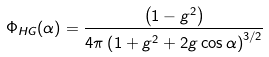Convert formula to latex. <formula><loc_0><loc_0><loc_500><loc_500>\Phi _ { H G } ( \alpha ) = \frac { \left ( 1 - g ^ { 2 } \right ) } { 4 \pi \left ( 1 + g ^ { 2 } + 2 g \cos \alpha \right ) ^ { 3 / 2 } }</formula> 